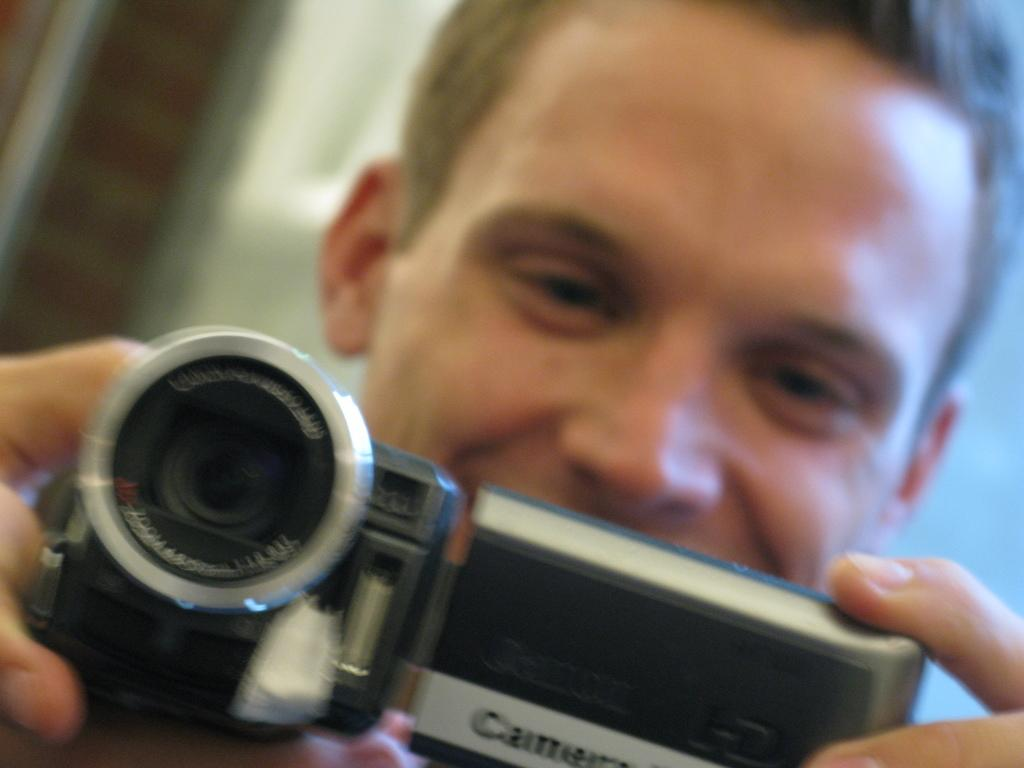What is the main subject of the image? There is a person in the image. What is the person doing in the image? The person is holding a camera with both hands and watching the camera's screen. Can you describe the background of the image? The background of the image is blurred. What type of design can be seen on the grape in the image? There is no grape present in the image, so it is not possible to answer that question. 